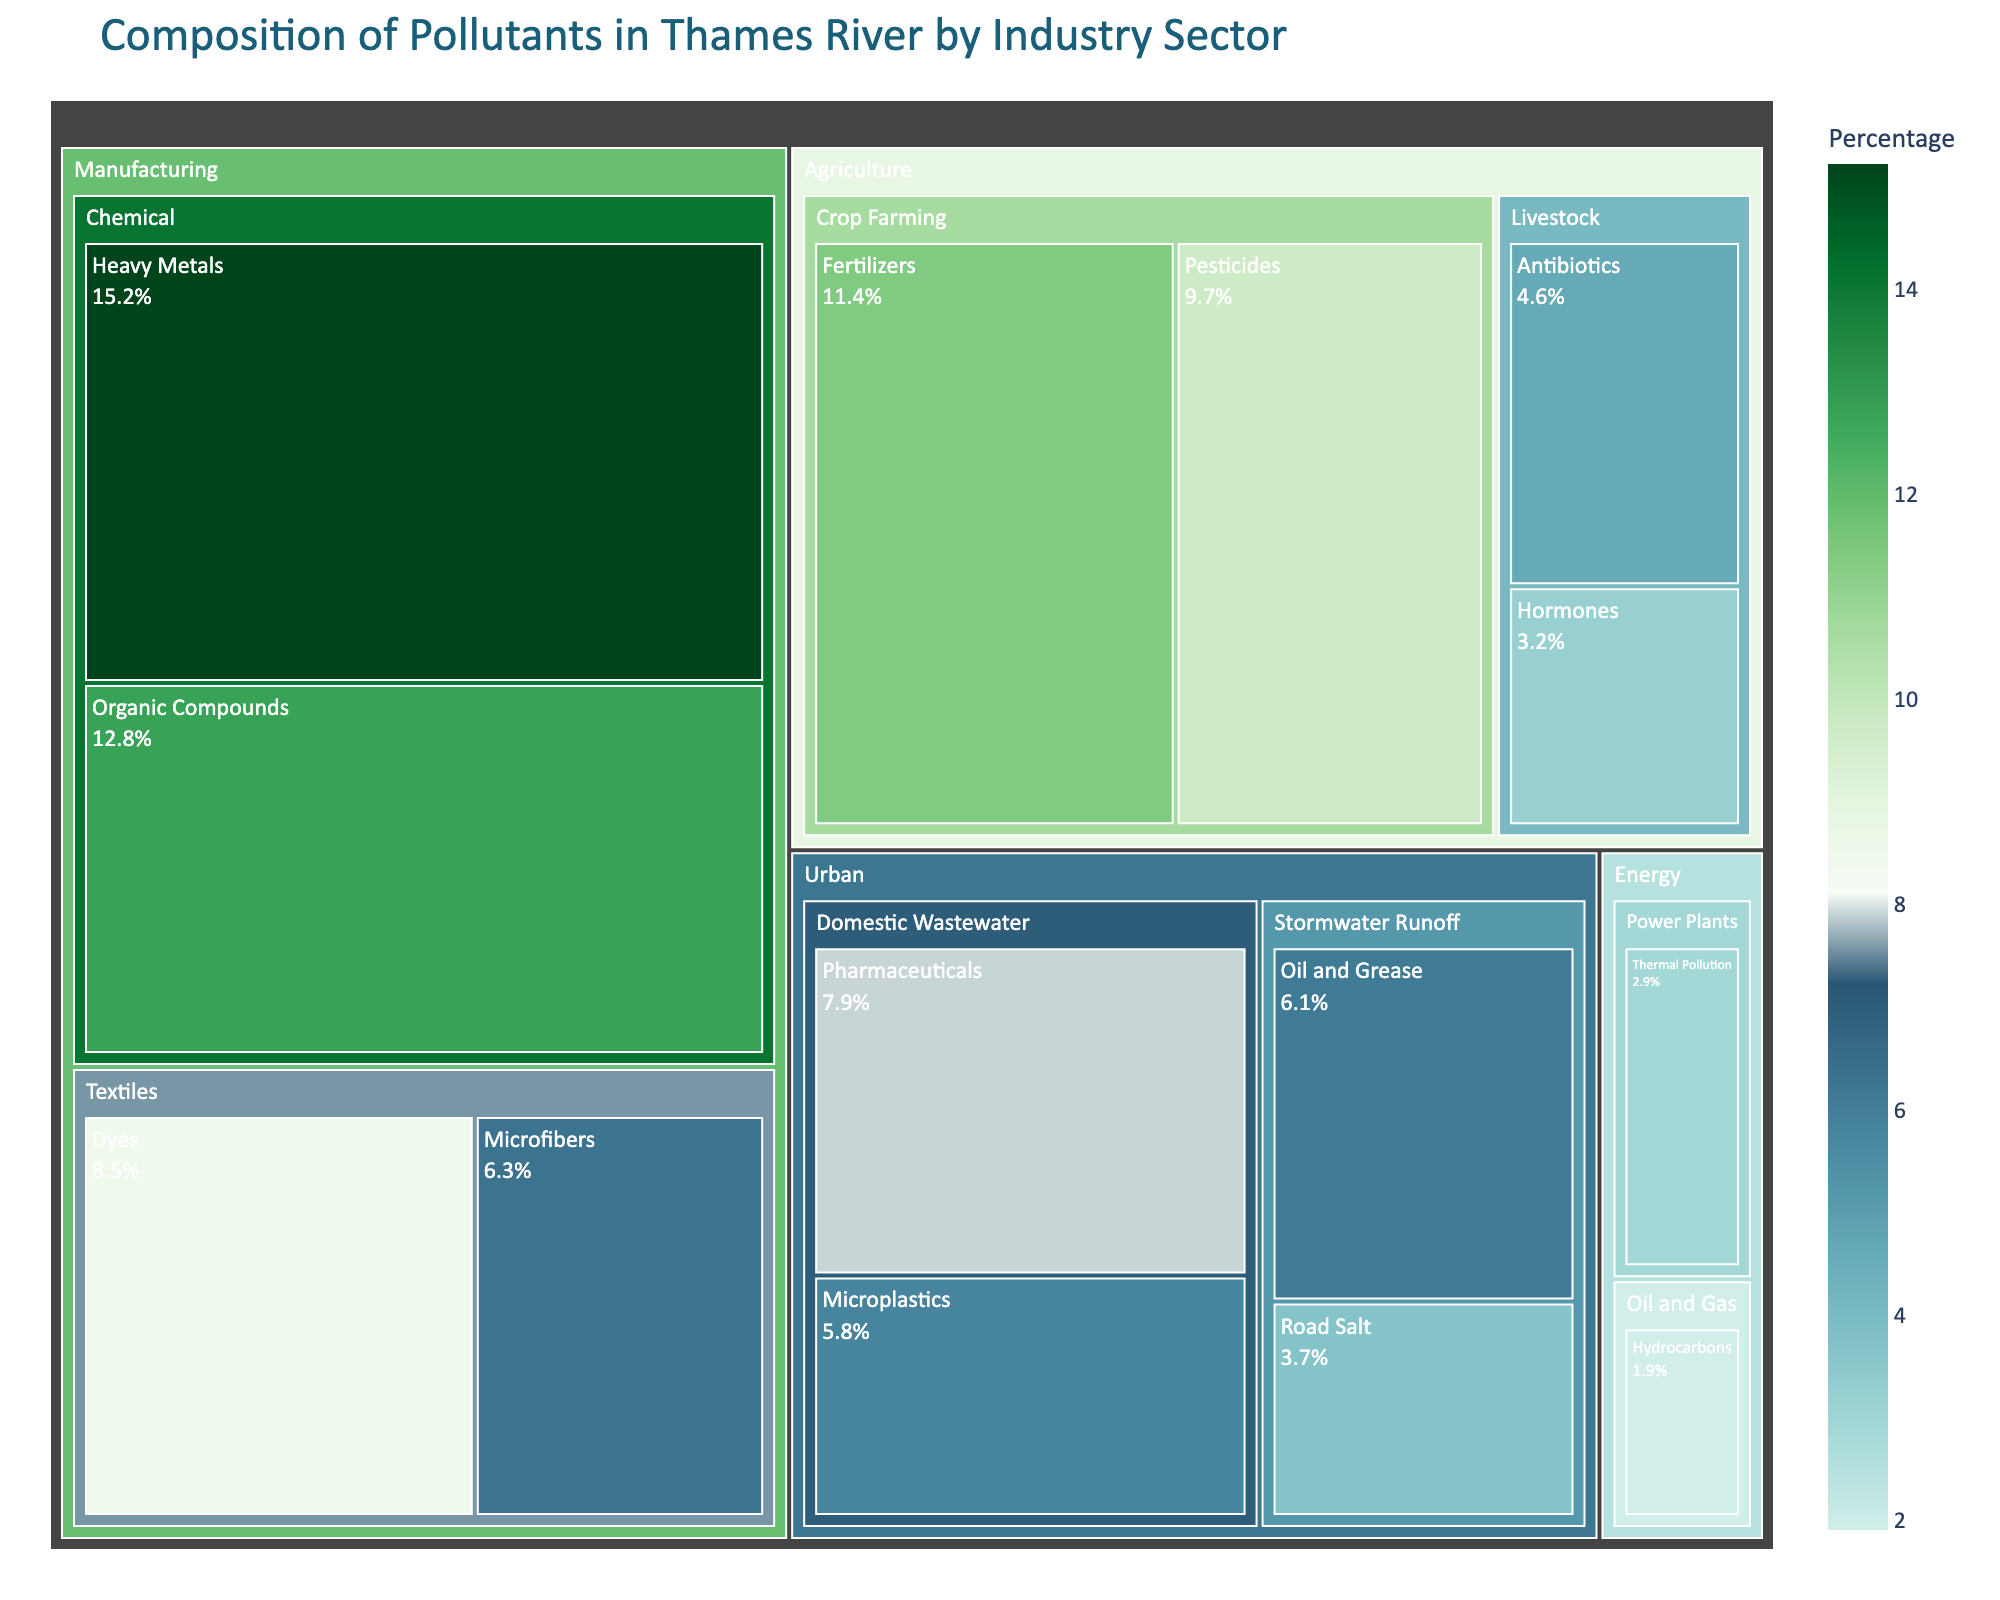What's the title of the treemap? The title is displayed at the top of the treemap, explaining the overall content. It reads "Composition of Pollutants in Thames River by Industry Sector".
Answer: Composition of Pollutants in Thames River by Industry Sector Which pollutant has the highest percentage in the treemap? By observing the size of the segments, we find the largest segment represents "Heavy Metals" under the "Manufacturing" sector, with a percentage of 15.2%.
Answer: Heavy Metals What is the combined percentage of pollutants from the Manufacturing sector? We need to add the percentages of Heavy Metals (15.2%), Organic Compounds (12.8%), Dyes (8.5%), and Microfibers (6.3%) in this sector: 15.2 + 12.8 + 8.5 + 6.3 = 42.8%.
Answer: 42.8% Compare the percentages of pollutants from Crop Farming and Livestock within the Agriculture sectors. Which one is higher? In Crop Farming, the pollutants sum up to 9.7% + 11.4% = 21.1%. In Livestock, they sum up to 4.6% + 3.2% = 7.8%. Therefore, Crop Farming contributes more.
Answer: Crop Farming How does the percentage of Organic Compounds compare to Microplastics? Organic Compounds have a percentage of 12.8%, while Microplastics have 5.8%. By subtracting, 12.8% - 5.8%, Organic Compounds are 7% higher than Microplastics.
Answer: Organic Compounds are 7% higher Which pollutants are represented in the Urban sector, and what are their total percentages? The pollutants in the Urban sector are Pharmaceuticals (7.9%), Microplastics (5.8%), Oil and Grease (6.1%), and Road Salt (3.7%). Adding these percentages gives 7.9 + 5.8 + 6.1 + 3.7 = 23.5%.
Answer: Pharmaceuticals, Microplastics, Oil and Grease, Road Salt; 23.5% What is the difference in percentage between the highest and lowest pollutants in the Energy sector? In the Energy sector, Thermal Pollution is 2.9% and Hydrocarbons are 1.9%. The difference is 2.9% - 1.9% = 1.0%.
Answer: 1.0% What's the median percentage of pollutants in the Agriculture sector? Considering the pollutants in the Agriculture sector and sorting their percentages: 3.2%, 4.6%, 9.7%, 11.4%, the median of these values is (4.6 + 9.7)/2 = 7.15%.
Answer: 7.15% Which sector contributes the most pollutants to the Thames River? By comparing the summed percentages of all sectors, the Manufacturing sector has the highest total percentage, 42.8%.
Answer: Manufacturing 